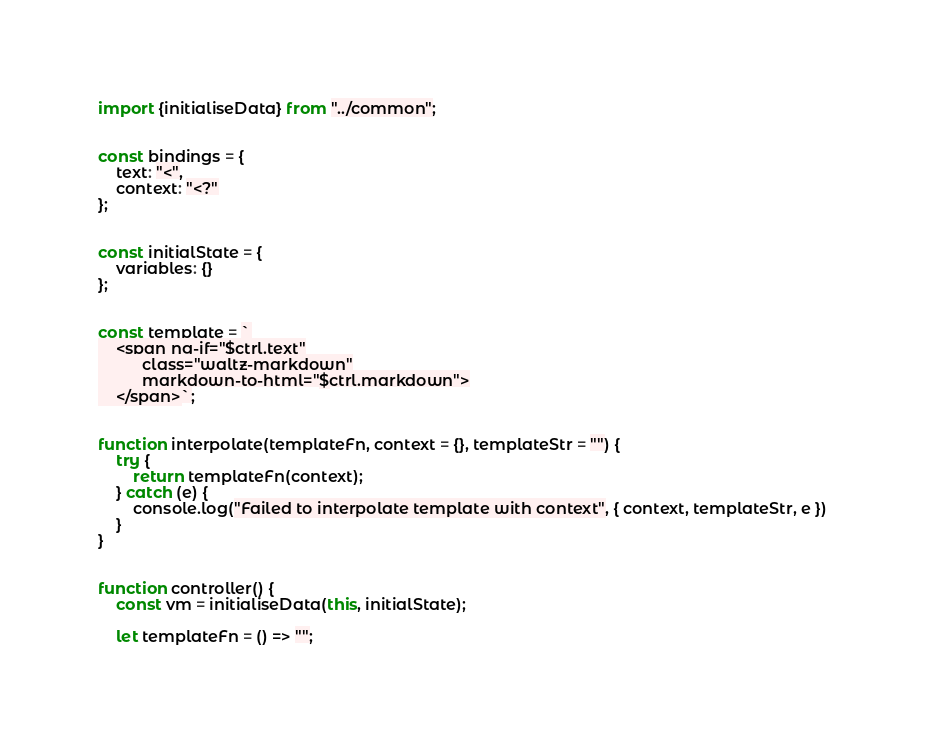Convert code to text. <code><loc_0><loc_0><loc_500><loc_500><_JavaScript_>import {initialiseData} from "../common";


const bindings = {
    text: "<",
    context: "<?"
};


const initialState = {
    variables: {}
};


const template = `
    <span ng-if="$ctrl.text"
          class="waltz-markdown"
          markdown-to-html="$ctrl.markdown">
    </span>`;


function interpolate(templateFn, context = {}, templateStr = "") {
    try {
        return templateFn(context);
    } catch (e) {
        console.log("Failed to interpolate template with context", { context, templateStr, e })
    }
}


function controller() {
    const vm = initialiseData(this, initialState);

    let templateFn = () => "";
</code> 